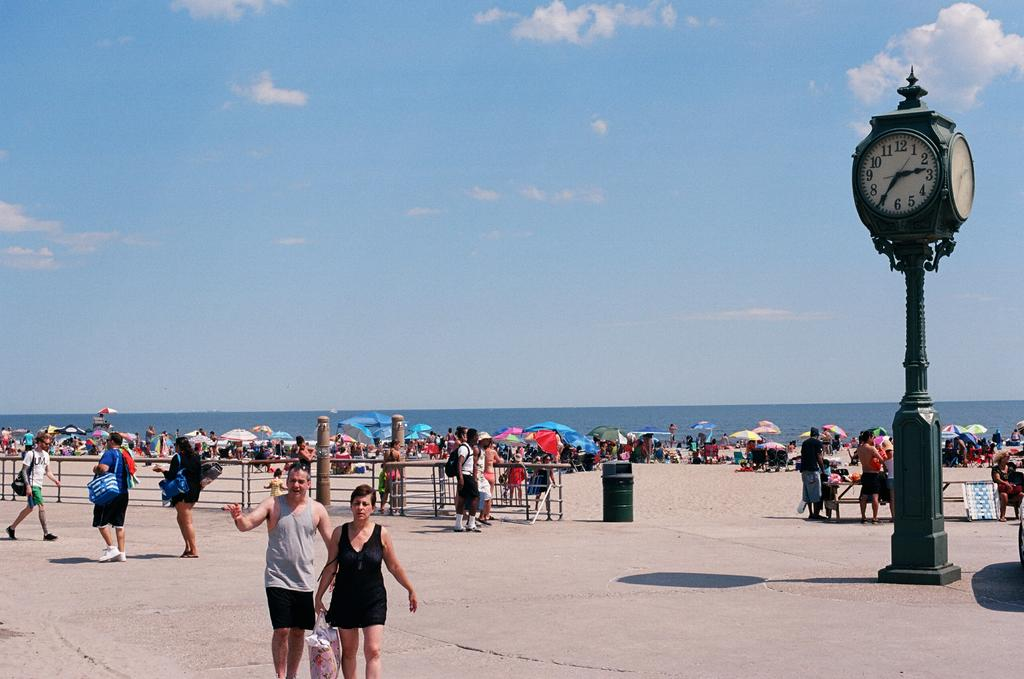What type of structure can be seen in the image? There is a fence in the image. What object is present for waste disposal? There is a dustbin in the image. Can you describe the people in the image? There is a group of people in the image. What type of seating is available in the image? There is a bench in the image. What are the people holding in the image? There are umbrellas in the image. What time-related object is present in the image? There is a clock in the image. What natural element is visible in the image? Water is visible in the image. What is visible at the top of the image? The sky is visible at the top of the image. What can be seen in the sky? Clouds are present in the sky. Reasoning: Let' Let's think step by step in order to produce the conversation. We start by identifying the main structures and objects in the image based on the provided facts. We then formulate questions that focus on the location and characteristics of these subjects and objects, ensuring that each question can be answered definitively with the information given. We avoid yes/no questions and ensure that the language is simple and clear. Absurd Question/Answer: What type of stew is being served in the image? There is no stew present in the image. Are the people wearing masks in the image? There is no mention of masks in the image. What type of system is being used to manage the people in the image? There is no system mentioned in the image; it simply shows a group of people. What type of stew is being served in the image? There is no stew present in the image. Are the people wearing masks in the image? There is no mention of masks in the image. What type of system is being used to manage the people in the image? There is no system mentioned in the image; it simply shows a group of people. 